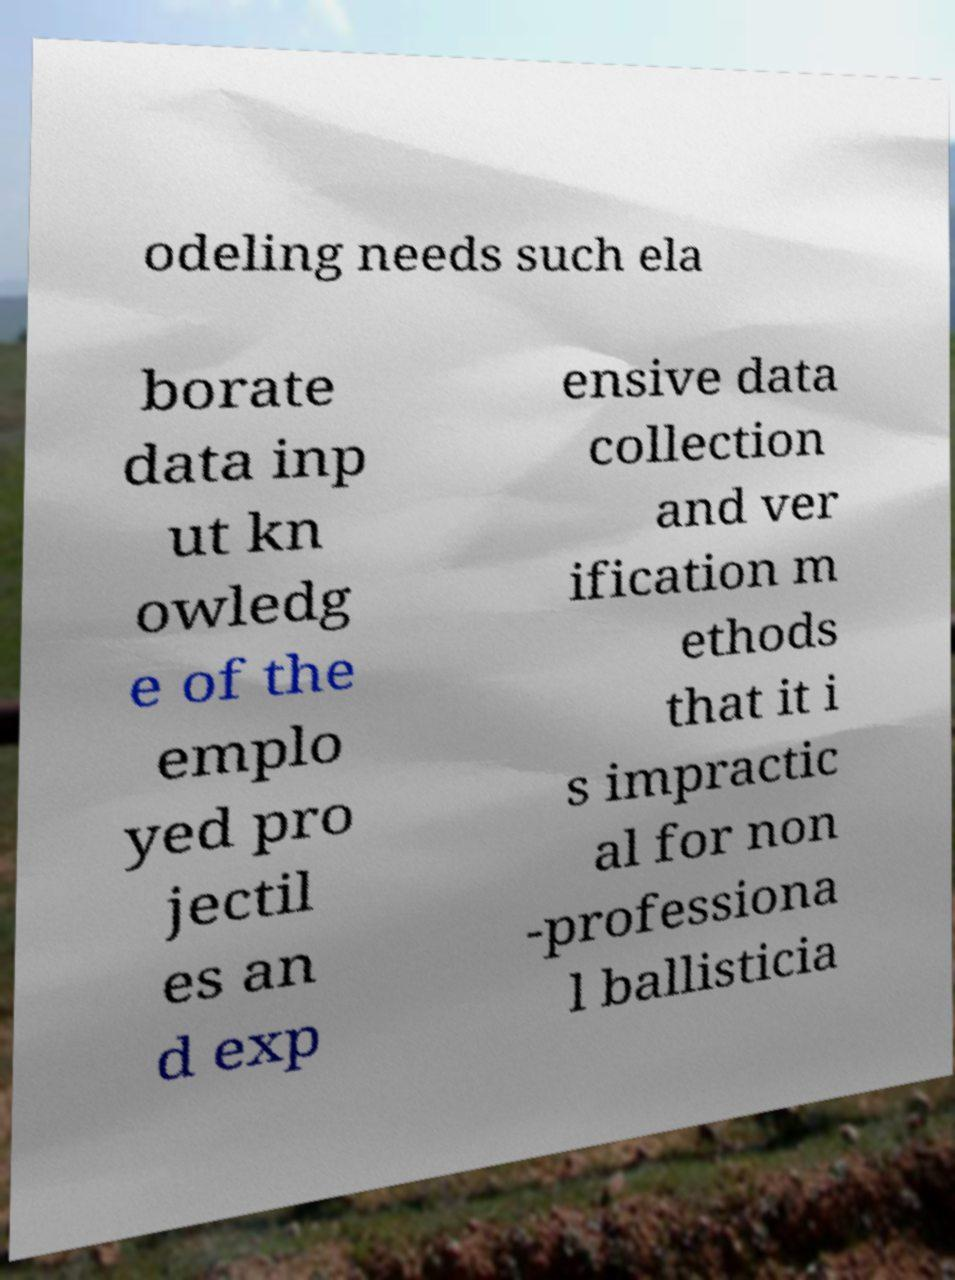Please identify and transcribe the text found in this image. odeling needs such ela borate data inp ut kn owledg e of the emplo yed pro jectil es an d exp ensive data collection and ver ification m ethods that it i s impractic al for non -professiona l ballisticia 